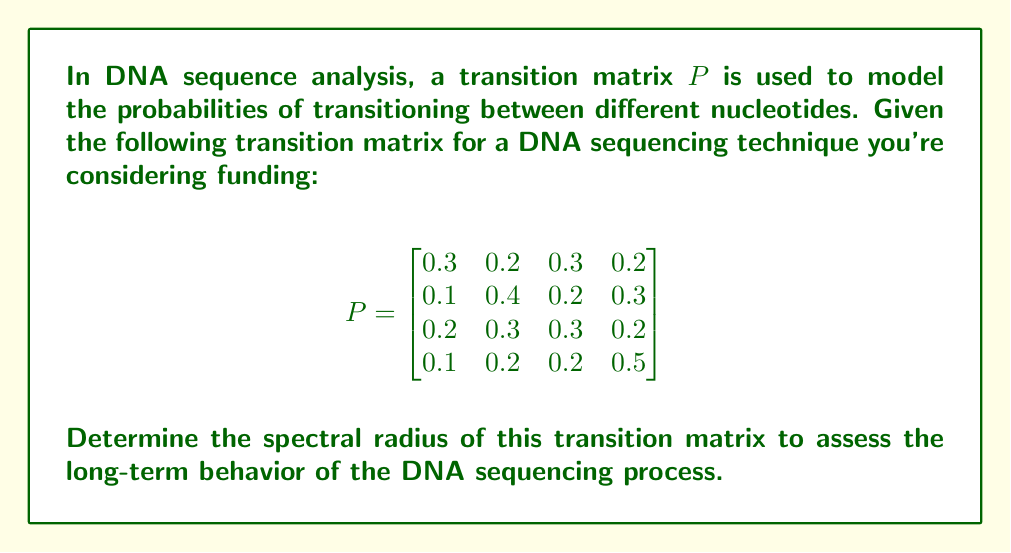Provide a solution to this math problem. To determine the spectral radius of the transition matrix $P$, we need to follow these steps:

1) First, recall that the spectral radius $\rho(P)$ is the largest absolute value of the eigenvalues of $P$.

2) To find the eigenvalues, we need to solve the characteristic equation:
   $\det(P - \lambda I) = 0$

3) Expanding this determinant:
   $$\begin{vmatrix}
   0.3-\lambda & 0.2 & 0.3 & 0.2 \\
   0.1 & 0.4-\lambda & 0.2 & 0.3 \\
   0.2 & 0.3 & 0.3-\lambda & 0.2 \\
   0.1 & 0.2 & 0.2 & 0.5-\lambda
   \end{vmatrix} = 0$$

4) This leads to a 4th degree polynomial equation. However, since $P$ is a stochastic matrix (each row sums to 1), we know that 1 is always an eigenvalue.

5) Factoring out $(\lambda - 1)$, we get a cubic equation:
   $(\lambda - 1)(\lambda^3 + a\lambda^2 + b\lambda + c) = 0$

6) Using numerical methods or computer algebra systems, we can find the roots of this cubic equation. The other eigenvalues are approximately:
   $\lambda_2 \approx 0.2631$
   $\lambda_3 \approx 0.1684 + 0.0831i$
   $\lambda_4 \approx 0.1684 - 0.0831i$

7) The absolute values of these eigenvalues are:
   $|\lambda_1| = 1$
   $|\lambda_2| \approx 0.2631$
   $|\lambda_3| = |\lambda_4| \approx 0.1876$

8) The spectral radius is the maximum of these values, which is 1.

This result is consistent with the Perron-Frobenius theorem for stochastic matrices, which states that the spectral radius of a stochastic matrix is always 1.
Answer: $\rho(P) = 1$ 